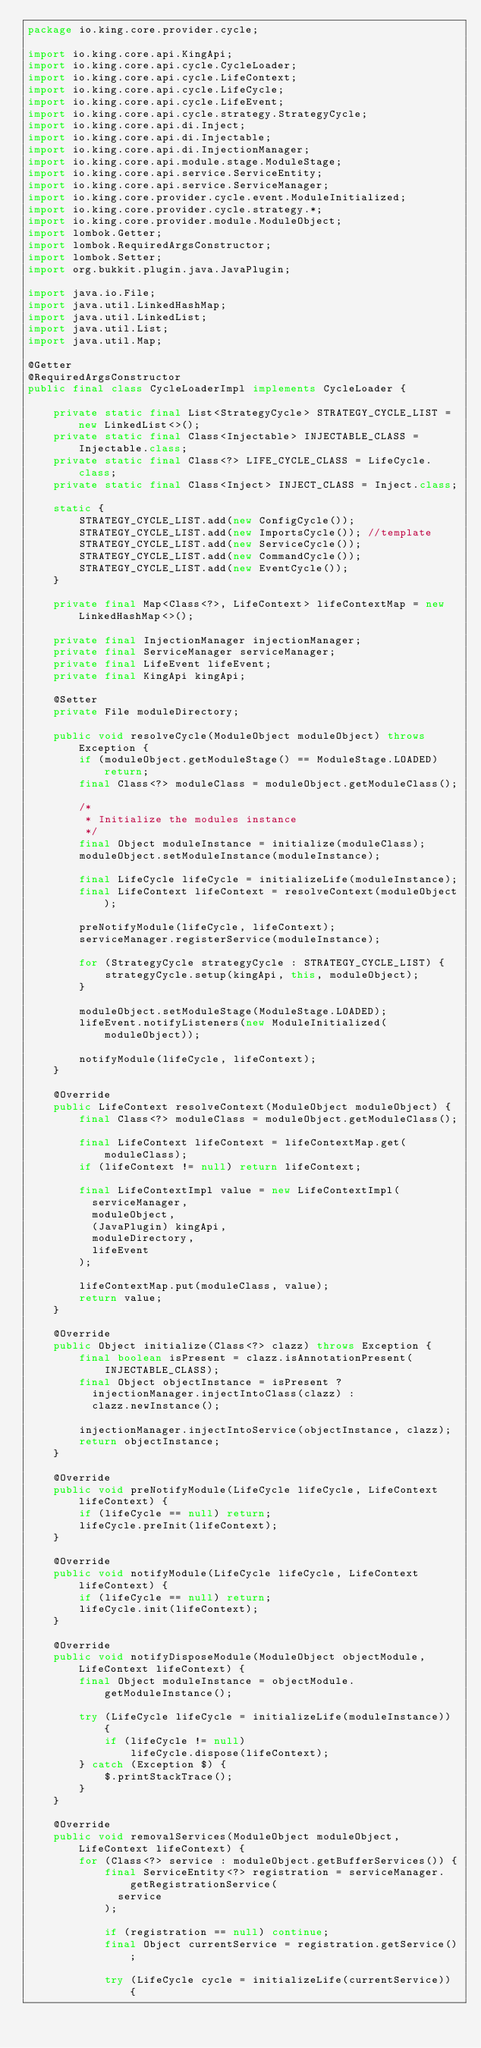<code> <loc_0><loc_0><loc_500><loc_500><_Java_>package io.king.core.provider.cycle;

import io.king.core.api.KingApi;
import io.king.core.api.cycle.CycleLoader;
import io.king.core.api.cycle.LifeContext;
import io.king.core.api.cycle.LifeCycle;
import io.king.core.api.cycle.LifeEvent;
import io.king.core.api.cycle.strategy.StrategyCycle;
import io.king.core.api.di.Inject;
import io.king.core.api.di.Injectable;
import io.king.core.api.di.InjectionManager;
import io.king.core.api.module.stage.ModuleStage;
import io.king.core.api.service.ServiceEntity;
import io.king.core.api.service.ServiceManager;
import io.king.core.provider.cycle.event.ModuleInitialized;
import io.king.core.provider.cycle.strategy.*;
import io.king.core.provider.module.ModuleObject;
import lombok.Getter;
import lombok.RequiredArgsConstructor;
import lombok.Setter;
import org.bukkit.plugin.java.JavaPlugin;

import java.io.File;
import java.util.LinkedHashMap;
import java.util.LinkedList;
import java.util.List;
import java.util.Map;

@Getter
@RequiredArgsConstructor
public final class CycleLoaderImpl implements CycleLoader {

    private static final List<StrategyCycle> STRATEGY_CYCLE_LIST = new LinkedList<>();
    private static final Class<Injectable> INJECTABLE_CLASS = Injectable.class;
    private static final Class<?> LIFE_CYCLE_CLASS = LifeCycle.class;
    private static final Class<Inject> INJECT_CLASS = Inject.class;

    static {
        STRATEGY_CYCLE_LIST.add(new ConfigCycle());
        STRATEGY_CYCLE_LIST.add(new ImportsCycle()); //template
        STRATEGY_CYCLE_LIST.add(new ServiceCycle());
        STRATEGY_CYCLE_LIST.add(new CommandCycle());
        STRATEGY_CYCLE_LIST.add(new EventCycle());
    }

    private final Map<Class<?>, LifeContext> lifeContextMap = new LinkedHashMap<>();

    private final InjectionManager injectionManager;
    private final ServiceManager serviceManager;
    private final LifeEvent lifeEvent;
    private final KingApi kingApi;

    @Setter
    private File moduleDirectory;

    public void resolveCycle(ModuleObject moduleObject) throws Exception {
        if (moduleObject.getModuleStage() == ModuleStage.LOADED) return;
        final Class<?> moduleClass = moduleObject.getModuleClass();

        /*
         * Initialize the modules instance
         */
        final Object moduleInstance = initialize(moduleClass);
        moduleObject.setModuleInstance(moduleInstance);

        final LifeCycle lifeCycle = initializeLife(moduleInstance);
        final LifeContext lifeContext = resolveContext(moduleObject);

        preNotifyModule(lifeCycle, lifeContext);
        serviceManager.registerService(moduleInstance);

        for (StrategyCycle strategyCycle : STRATEGY_CYCLE_LIST) {
            strategyCycle.setup(kingApi, this, moduleObject);
        }

        moduleObject.setModuleStage(ModuleStage.LOADED);
        lifeEvent.notifyListeners(new ModuleInitialized(moduleObject));

        notifyModule(lifeCycle, lifeContext);
    }

    @Override
    public LifeContext resolveContext(ModuleObject moduleObject) {
        final Class<?> moduleClass = moduleObject.getModuleClass();

        final LifeContext lifeContext = lifeContextMap.get(moduleClass);
        if (lifeContext != null) return lifeContext;

        final LifeContextImpl value = new LifeContextImpl(
          serviceManager,
          moduleObject,
          (JavaPlugin) kingApi,
          moduleDirectory,
          lifeEvent
        );

        lifeContextMap.put(moduleClass, value);
        return value;
    }

    @Override
    public Object initialize(Class<?> clazz) throws Exception {
        final boolean isPresent = clazz.isAnnotationPresent(INJECTABLE_CLASS);
        final Object objectInstance = isPresent ?
          injectionManager.injectIntoClass(clazz) :
          clazz.newInstance();

        injectionManager.injectIntoService(objectInstance, clazz);
        return objectInstance;
    }

    @Override
    public void preNotifyModule(LifeCycle lifeCycle, LifeContext lifeContext) {
        if (lifeCycle == null) return;
        lifeCycle.preInit(lifeContext);
    }

    @Override
    public void notifyModule(LifeCycle lifeCycle, LifeContext lifeContext) {
        if (lifeCycle == null) return;
        lifeCycle.init(lifeContext);
    }

    @Override
    public void notifyDisposeModule(ModuleObject objectModule, LifeContext lifeContext) {
        final Object moduleInstance = objectModule.getModuleInstance();

        try (LifeCycle lifeCycle = initializeLife(moduleInstance)) {
            if (lifeCycle != null)
                lifeCycle.dispose(lifeContext);
        } catch (Exception $) {
            $.printStackTrace();
        }
    }

    @Override
    public void removalServices(ModuleObject moduleObject, LifeContext lifeContext) {
        for (Class<?> service : moduleObject.getBufferServices()) {
            final ServiceEntity<?> registration = serviceManager.getRegistrationService(
              service
            );

            if (registration == null) continue;
            final Object currentService = registration.getService();

            try (LifeCycle cycle = initializeLife(currentService)) {</code> 